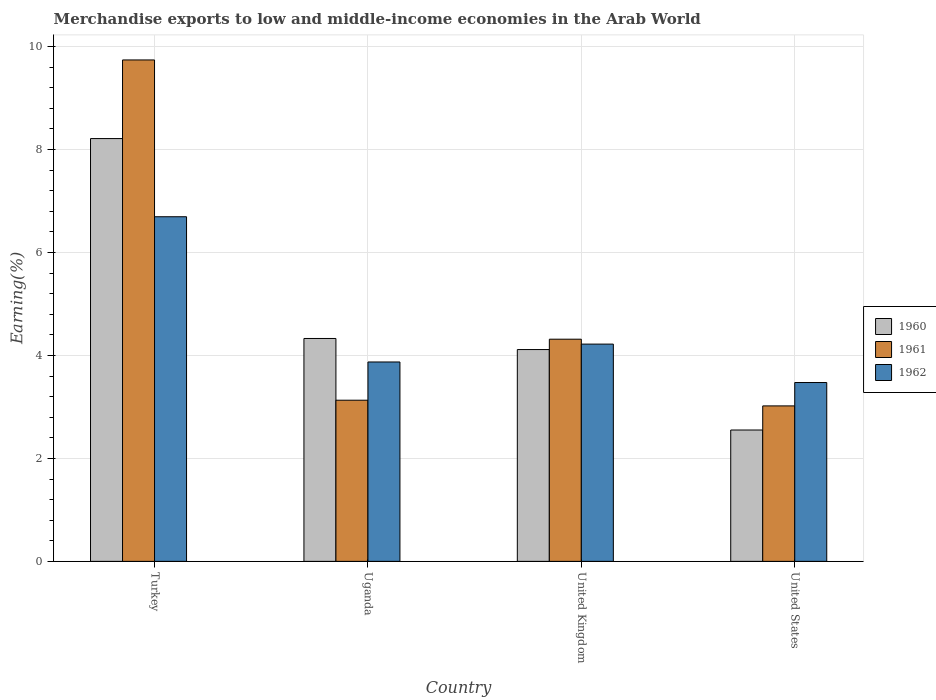How many bars are there on the 1st tick from the left?
Give a very brief answer. 3. How many bars are there on the 3rd tick from the right?
Keep it short and to the point. 3. What is the label of the 1st group of bars from the left?
Offer a very short reply. Turkey. In how many cases, is the number of bars for a given country not equal to the number of legend labels?
Provide a succinct answer. 0. What is the percentage of amount earned from merchandise exports in 1960 in United States?
Provide a succinct answer. 2.55. Across all countries, what is the maximum percentage of amount earned from merchandise exports in 1960?
Your answer should be compact. 8.21. Across all countries, what is the minimum percentage of amount earned from merchandise exports in 1961?
Make the answer very short. 3.02. In which country was the percentage of amount earned from merchandise exports in 1961 maximum?
Offer a very short reply. Turkey. In which country was the percentage of amount earned from merchandise exports in 1960 minimum?
Offer a terse response. United States. What is the total percentage of amount earned from merchandise exports in 1960 in the graph?
Keep it short and to the point. 19.21. What is the difference between the percentage of amount earned from merchandise exports in 1960 in Uganda and that in United States?
Make the answer very short. 1.78. What is the difference between the percentage of amount earned from merchandise exports in 1961 in Turkey and the percentage of amount earned from merchandise exports in 1962 in United Kingdom?
Offer a very short reply. 5.52. What is the average percentage of amount earned from merchandise exports in 1962 per country?
Offer a very short reply. 4.57. What is the difference between the percentage of amount earned from merchandise exports of/in 1961 and percentage of amount earned from merchandise exports of/in 1960 in United Kingdom?
Your response must be concise. 0.2. In how many countries, is the percentage of amount earned from merchandise exports in 1961 greater than 4.8 %?
Offer a terse response. 1. What is the ratio of the percentage of amount earned from merchandise exports in 1962 in Uganda to that in United States?
Your response must be concise. 1.11. What is the difference between the highest and the second highest percentage of amount earned from merchandise exports in 1962?
Your response must be concise. -0.35. What is the difference between the highest and the lowest percentage of amount earned from merchandise exports in 1960?
Your answer should be compact. 5.66. In how many countries, is the percentage of amount earned from merchandise exports in 1962 greater than the average percentage of amount earned from merchandise exports in 1962 taken over all countries?
Offer a very short reply. 1. Is the sum of the percentage of amount earned from merchandise exports in 1961 in Uganda and United States greater than the maximum percentage of amount earned from merchandise exports in 1960 across all countries?
Ensure brevity in your answer.  No. What does the 1st bar from the right in United Kingdom represents?
Offer a very short reply. 1962. Is it the case that in every country, the sum of the percentage of amount earned from merchandise exports in 1961 and percentage of amount earned from merchandise exports in 1962 is greater than the percentage of amount earned from merchandise exports in 1960?
Offer a very short reply. Yes. Are all the bars in the graph horizontal?
Your response must be concise. No. What is the difference between two consecutive major ticks on the Y-axis?
Provide a succinct answer. 2. Does the graph contain any zero values?
Your answer should be very brief. No. Where does the legend appear in the graph?
Your answer should be very brief. Center right. How many legend labels are there?
Make the answer very short. 3. How are the legend labels stacked?
Provide a succinct answer. Vertical. What is the title of the graph?
Ensure brevity in your answer.  Merchandise exports to low and middle-income economies in the Arab World. What is the label or title of the X-axis?
Your answer should be compact. Country. What is the label or title of the Y-axis?
Your answer should be compact. Earning(%). What is the Earning(%) in 1960 in Turkey?
Your response must be concise. 8.21. What is the Earning(%) of 1961 in Turkey?
Provide a succinct answer. 9.74. What is the Earning(%) of 1962 in Turkey?
Make the answer very short. 6.69. What is the Earning(%) in 1960 in Uganda?
Keep it short and to the point. 4.33. What is the Earning(%) in 1961 in Uganda?
Give a very brief answer. 3.13. What is the Earning(%) in 1962 in Uganda?
Provide a succinct answer. 3.87. What is the Earning(%) of 1960 in United Kingdom?
Make the answer very short. 4.11. What is the Earning(%) of 1961 in United Kingdom?
Provide a succinct answer. 4.32. What is the Earning(%) of 1962 in United Kingdom?
Your answer should be very brief. 4.22. What is the Earning(%) of 1960 in United States?
Your answer should be very brief. 2.55. What is the Earning(%) of 1961 in United States?
Provide a short and direct response. 3.02. What is the Earning(%) of 1962 in United States?
Provide a succinct answer. 3.47. Across all countries, what is the maximum Earning(%) in 1960?
Your answer should be compact. 8.21. Across all countries, what is the maximum Earning(%) in 1961?
Give a very brief answer. 9.74. Across all countries, what is the maximum Earning(%) of 1962?
Offer a very short reply. 6.69. Across all countries, what is the minimum Earning(%) in 1960?
Provide a succinct answer. 2.55. Across all countries, what is the minimum Earning(%) of 1961?
Make the answer very short. 3.02. Across all countries, what is the minimum Earning(%) of 1962?
Ensure brevity in your answer.  3.47. What is the total Earning(%) of 1960 in the graph?
Offer a terse response. 19.21. What is the total Earning(%) in 1961 in the graph?
Make the answer very short. 20.21. What is the total Earning(%) of 1962 in the graph?
Give a very brief answer. 18.26. What is the difference between the Earning(%) of 1960 in Turkey and that in Uganda?
Offer a very short reply. 3.88. What is the difference between the Earning(%) of 1961 in Turkey and that in Uganda?
Offer a terse response. 6.61. What is the difference between the Earning(%) in 1962 in Turkey and that in Uganda?
Provide a succinct answer. 2.82. What is the difference between the Earning(%) of 1960 in Turkey and that in United Kingdom?
Offer a very short reply. 4.1. What is the difference between the Earning(%) in 1961 in Turkey and that in United Kingdom?
Provide a short and direct response. 5.42. What is the difference between the Earning(%) of 1962 in Turkey and that in United Kingdom?
Your response must be concise. 2.47. What is the difference between the Earning(%) in 1960 in Turkey and that in United States?
Your answer should be compact. 5.66. What is the difference between the Earning(%) in 1961 in Turkey and that in United States?
Provide a succinct answer. 6.72. What is the difference between the Earning(%) in 1962 in Turkey and that in United States?
Make the answer very short. 3.22. What is the difference between the Earning(%) of 1960 in Uganda and that in United Kingdom?
Make the answer very short. 0.21. What is the difference between the Earning(%) of 1961 in Uganda and that in United Kingdom?
Your answer should be compact. -1.19. What is the difference between the Earning(%) in 1962 in Uganda and that in United Kingdom?
Offer a very short reply. -0.35. What is the difference between the Earning(%) of 1960 in Uganda and that in United States?
Offer a terse response. 1.78. What is the difference between the Earning(%) of 1961 in Uganda and that in United States?
Your answer should be compact. 0.11. What is the difference between the Earning(%) in 1962 in Uganda and that in United States?
Keep it short and to the point. 0.4. What is the difference between the Earning(%) of 1960 in United Kingdom and that in United States?
Provide a succinct answer. 1.56. What is the difference between the Earning(%) in 1961 in United Kingdom and that in United States?
Provide a succinct answer. 1.3. What is the difference between the Earning(%) of 1962 in United Kingdom and that in United States?
Offer a terse response. 0.75. What is the difference between the Earning(%) of 1960 in Turkey and the Earning(%) of 1961 in Uganda?
Give a very brief answer. 5.08. What is the difference between the Earning(%) of 1960 in Turkey and the Earning(%) of 1962 in Uganda?
Make the answer very short. 4.34. What is the difference between the Earning(%) of 1961 in Turkey and the Earning(%) of 1962 in Uganda?
Offer a terse response. 5.87. What is the difference between the Earning(%) of 1960 in Turkey and the Earning(%) of 1961 in United Kingdom?
Your answer should be compact. 3.9. What is the difference between the Earning(%) of 1960 in Turkey and the Earning(%) of 1962 in United Kingdom?
Provide a succinct answer. 3.99. What is the difference between the Earning(%) of 1961 in Turkey and the Earning(%) of 1962 in United Kingdom?
Offer a very short reply. 5.52. What is the difference between the Earning(%) in 1960 in Turkey and the Earning(%) in 1961 in United States?
Your answer should be compact. 5.19. What is the difference between the Earning(%) in 1960 in Turkey and the Earning(%) in 1962 in United States?
Offer a very short reply. 4.74. What is the difference between the Earning(%) of 1961 in Turkey and the Earning(%) of 1962 in United States?
Offer a very short reply. 6.27. What is the difference between the Earning(%) of 1960 in Uganda and the Earning(%) of 1961 in United Kingdom?
Offer a terse response. 0.01. What is the difference between the Earning(%) of 1960 in Uganda and the Earning(%) of 1962 in United Kingdom?
Provide a short and direct response. 0.11. What is the difference between the Earning(%) in 1961 in Uganda and the Earning(%) in 1962 in United Kingdom?
Make the answer very short. -1.09. What is the difference between the Earning(%) in 1960 in Uganda and the Earning(%) in 1961 in United States?
Keep it short and to the point. 1.31. What is the difference between the Earning(%) of 1960 in Uganda and the Earning(%) of 1962 in United States?
Keep it short and to the point. 0.86. What is the difference between the Earning(%) in 1961 in Uganda and the Earning(%) in 1962 in United States?
Your response must be concise. -0.34. What is the difference between the Earning(%) of 1960 in United Kingdom and the Earning(%) of 1961 in United States?
Your response must be concise. 1.09. What is the difference between the Earning(%) of 1960 in United Kingdom and the Earning(%) of 1962 in United States?
Make the answer very short. 0.64. What is the difference between the Earning(%) of 1961 in United Kingdom and the Earning(%) of 1962 in United States?
Provide a short and direct response. 0.84. What is the average Earning(%) in 1960 per country?
Provide a short and direct response. 4.8. What is the average Earning(%) in 1961 per country?
Your answer should be compact. 5.05. What is the average Earning(%) of 1962 per country?
Your answer should be compact. 4.57. What is the difference between the Earning(%) of 1960 and Earning(%) of 1961 in Turkey?
Your response must be concise. -1.53. What is the difference between the Earning(%) in 1960 and Earning(%) in 1962 in Turkey?
Offer a very short reply. 1.52. What is the difference between the Earning(%) of 1961 and Earning(%) of 1962 in Turkey?
Offer a terse response. 3.05. What is the difference between the Earning(%) of 1960 and Earning(%) of 1961 in Uganda?
Offer a very short reply. 1.2. What is the difference between the Earning(%) in 1960 and Earning(%) in 1962 in Uganda?
Keep it short and to the point. 0.46. What is the difference between the Earning(%) of 1961 and Earning(%) of 1962 in Uganda?
Keep it short and to the point. -0.74. What is the difference between the Earning(%) in 1960 and Earning(%) in 1961 in United Kingdom?
Your answer should be very brief. -0.2. What is the difference between the Earning(%) in 1960 and Earning(%) in 1962 in United Kingdom?
Offer a very short reply. -0.11. What is the difference between the Earning(%) in 1961 and Earning(%) in 1962 in United Kingdom?
Provide a succinct answer. 0.1. What is the difference between the Earning(%) in 1960 and Earning(%) in 1961 in United States?
Your answer should be very brief. -0.47. What is the difference between the Earning(%) of 1960 and Earning(%) of 1962 in United States?
Offer a terse response. -0.92. What is the difference between the Earning(%) in 1961 and Earning(%) in 1962 in United States?
Your response must be concise. -0.45. What is the ratio of the Earning(%) in 1960 in Turkey to that in Uganda?
Offer a very short reply. 1.9. What is the ratio of the Earning(%) in 1961 in Turkey to that in Uganda?
Make the answer very short. 3.11. What is the ratio of the Earning(%) of 1962 in Turkey to that in Uganda?
Give a very brief answer. 1.73. What is the ratio of the Earning(%) of 1960 in Turkey to that in United Kingdom?
Provide a short and direct response. 2. What is the ratio of the Earning(%) of 1961 in Turkey to that in United Kingdom?
Make the answer very short. 2.26. What is the ratio of the Earning(%) of 1962 in Turkey to that in United Kingdom?
Your response must be concise. 1.59. What is the ratio of the Earning(%) of 1960 in Turkey to that in United States?
Your response must be concise. 3.22. What is the ratio of the Earning(%) of 1961 in Turkey to that in United States?
Provide a succinct answer. 3.23. What is the ratio of the Earning(%) in 1962 in Turkey to that in United States?
Make the answer very short. 1.93. What is the ratio of the Earning(%) in 1960 in Uganda to that in United Kingdom?
Your answer should be very brief. 1.05. What is the ratio of the Earning(%) of 1961 in Uganda to that in United Kingdom?
Your response must be concise. 0.73. What is the ratio of the Earning(%) of 1962 in Uganda to that in United Kingdom?
Make the answer very short. 0.92. What is the ratio of the Earning(%) in 1960 in Uganda to that in United States?
Keep it short and to the point. 1.7. What is the ratio of the Earning(%) of 1961 in Uganda to that in United States?
Keep it short and to the point. 1.04. What is the ratio of the Earning(%) of 1962 in Uganda to that in United States?
Provide a succinct answer. 1.11. What is the ratio of the Earning(%) of 1960 in United Kingdom to that in United States?
Offer a very short reply. 1.61. What is the ratio of the Earning(%) of 1961 in United Kingdom to that in United States?
Provide a short and direct response. 1.43. What is the ratio of the Earning(%) of 1962 in United Kingdom to that in United States?
Give a very brief answer. 1.21. What is the difference between the highest and the second highest Earning(%) in 1960?
Your answer should be compact. 3.88. What is the difference between the highest and the second highest Earning(%) in 1961?
Provide a short and direct response. 5.42. What is the difference between the highest and the second highest Earning(%) of 1962?
Provide a short and direct response. 2.47. What is the difference between the highest and the lowest Earning(%) in 1960?
Your response must be concise. 5.66. What is the difference between the highest and the lowest Earning(%) in 1961?
Make the answer very short. 6.72. What is the difference between the highest and the lowest Earning(%) in 1962?
Your response must be concise. 3.22. 